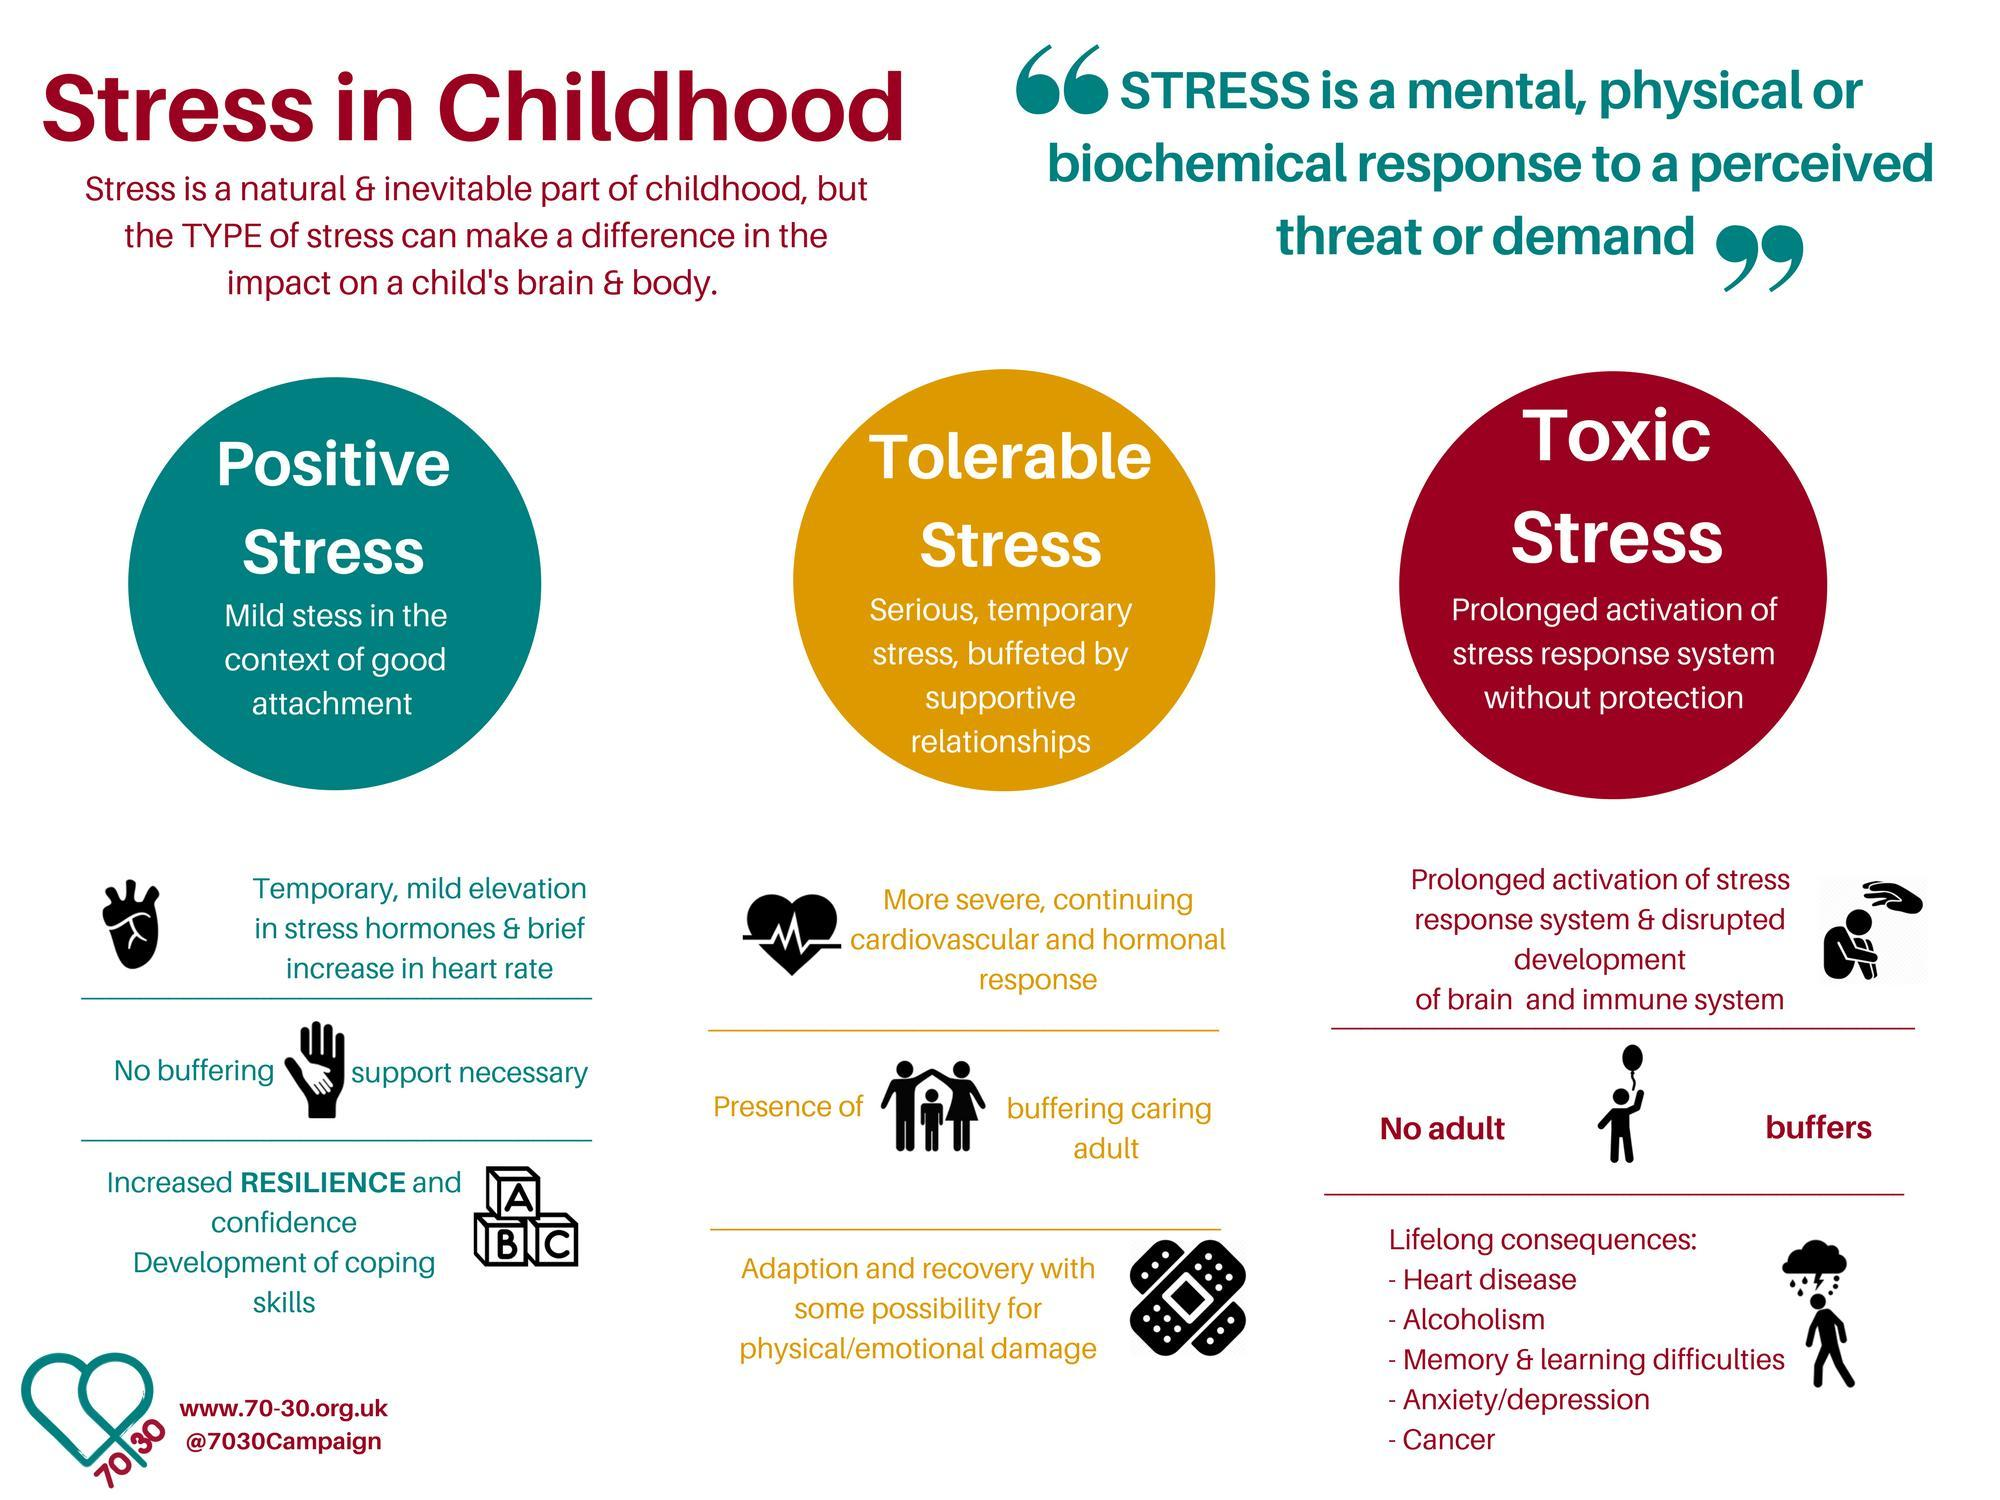What types of stresses are mentioned?
Answer the question with a short phrase. Positive Stress, Tolerable Stress, Toxic Stress 